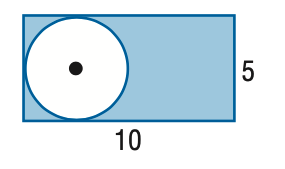Question: Find the area of the shaded region. Assume that all polygons that appear to be regular are regular. Round to the nearest tenth.
Choices:
A. 25
B. 28.5
C. 30.4
D. 50
Answer with the letter. Answer: C 